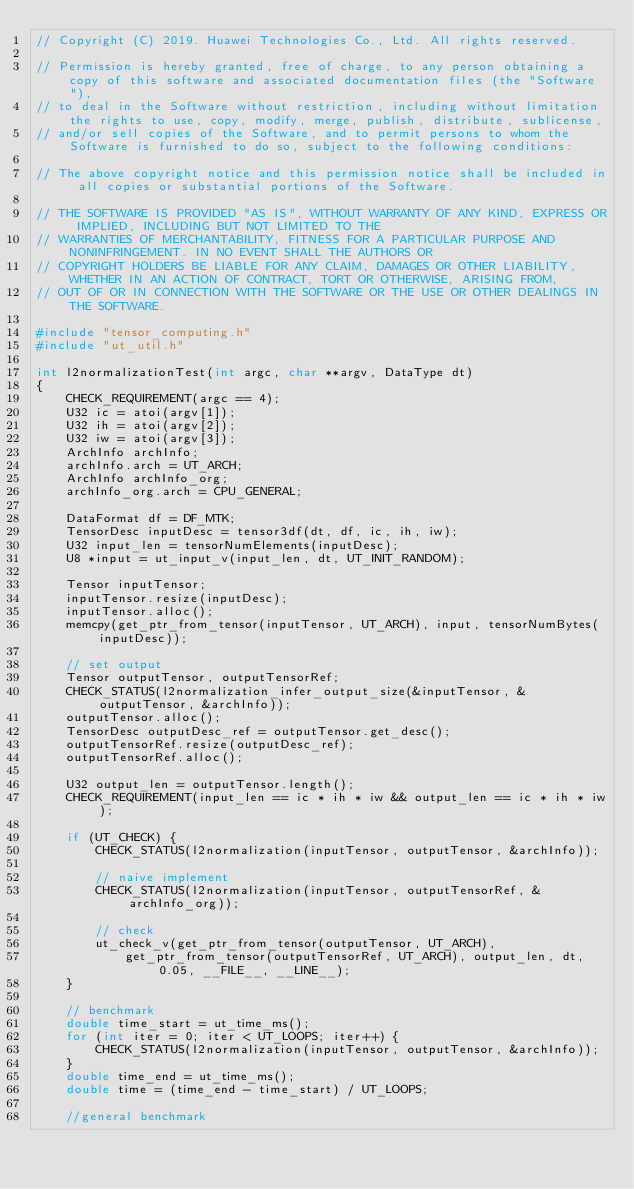Convert code to text. <code><loc_0><loc_0><loc_500><loc_500><_C++_>// Copyright (C) 2019. Huawei Technologies Co., Ltd. All rights reserved.

// Permission is hereby granted, free of charge, to any person obtaining a copy of this software and associated documentation files (the "Software"),
// to deal in the Software without restriction, including without limitation the rights to use, copy, modify, merge, publish, distribute, sublicense,
// and/or sell copies of the Software, and to permit persons to whom the Software is furnished to do so, subject to the following conditions:

// The above copyright notice and this permission notice shall be included in all copies or substantial portions of the Software.

// THE SOFTWARE IS PROVIDED "AS IS", WITHOUT WARRANTY OF ANY KIND, EXPRESS OR IMPLIED, INCLUDING BUT NOT LIMITED TO THE
// WARRANTIES OF MERCHANTABILITY, FITNESS FOR A PARTICULAR PURPOSE AND NONINFRINGEMENT. IN NO EVENT SHALL THE AUTHORS OR
// COPYRIGHT HOLDERS BE LIABLE FOR ANY CLAIM, DAMAGES OR OTHER LIABILITY, WHETHER IN AN ACTION OF CONTRACT, TORT OR OTHERWISE, ARISING FROM,
// OUT OF OR IN CONNECTION WITH THE SOFTWARE OR THE USE OR OTHER DEALINGS IN THE SOFTWARE.

#include "tensor_computing.h"
#include "ut_util.h"

int l2normalizationTest(int argc, char **argv, DataType dt)
{
    CHECK_REQUIREMENT(argc == 4);
    U32 ic = atoi(argv[1]);
    U32 ih = atoi(argv[2]);
    U32 iw = atoi(argv[3]);
    ArchInfo archInfo;
    archInfo.arch = UT_ARCH;
    ArchInfo archInfo_org;
    archInfo_org.arch = CPU_GENERAL;

    DataFormat df = DF_MTK;
    TensorDesc inputDesc = tensor3df(dt, df, ic, ih, iw);
    U32 input_len = tensorNumElements(inputDesc);
    U8 *input = ut_input_v(input_len, dt, UT_INIT_RANDOM);

    Tensor inputTensor;
    inputTensor.resize(inputDesc);
    inputTensor.alloc();
    memcpy(get_ptr_from_tensor(inputTensor, UT_ARCH), input, tensorNumBytes(inputDesc));

    // set output
    Tensor outputTensor, outputTensorRef;
    CHECK_STATUS(l2normalization_infer_output_size(&inputTensor, &outputTensor, &archInfo));
    outputTensor.alloc();
    TensorDesc outputDesc_ref = outputTensor.get_desc();
    outputTensorRef.resize(outputDesc_ref);
    outputTensorRef.alloc();

    U32 output_len = outputTensor.length();
    CHECK_REQUIREMENT(input_len == ic * ih * iw && output_len == ic * ih * iw);

    if (UT_CHECK) {
        CHECK_STATUS(l2normalization(inputTensor, outputTensor, &archInfo));

        // naive implement
        CHECK_STATUS(l2normalization(inputTensor, outputTensorRef, &archInfo_org));

        // check
        ut_check_v(get_ptr_from_tensor(outputTensor, UT_ARCH),
            get_ptr_from_tensor(outputTensorRef, UT_ARCH), output_len, dt, 0.05, __FILE__, __LINE__);
    }

    // benchmark
    double time_start = ut_time_ms();
    for (int iter = 0; iter < UT_LOOPS; iter++) {
        CHECK_STATUS(l2normalization(inputTensor, outputTensor, &archInfo));
    }
    double time_end = ut_time_ms();
    double time = (time_end - time_start) / UT_LOOPS;

    //general benchmark</code> 